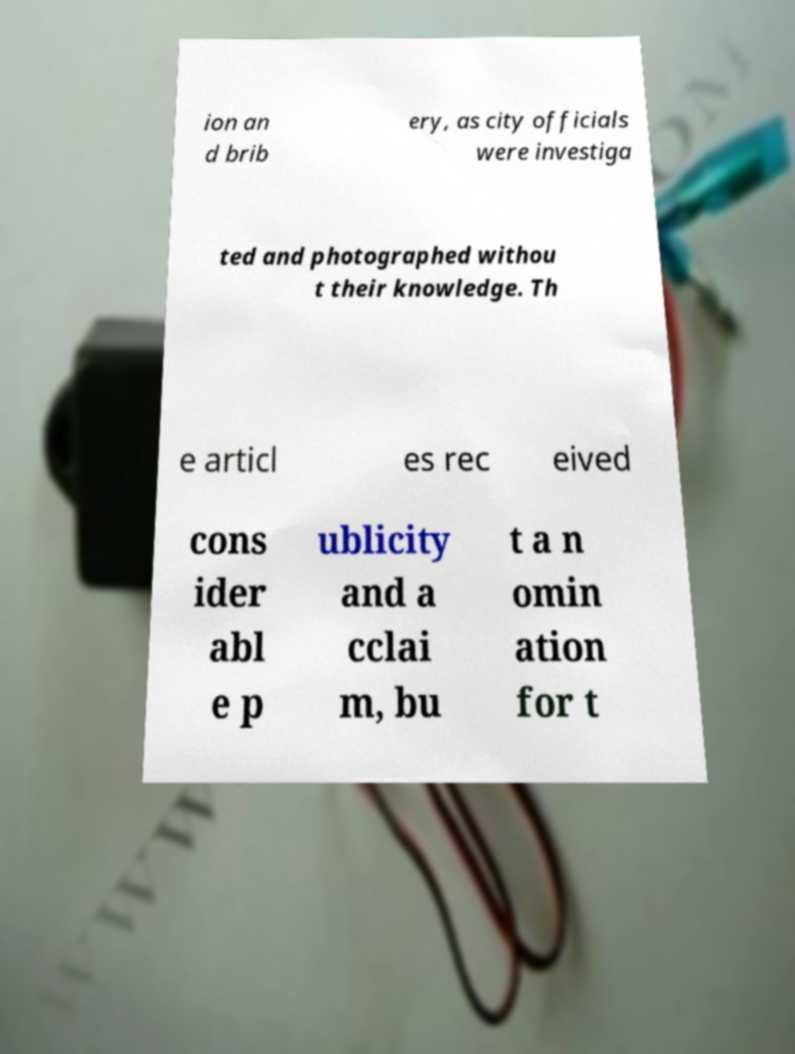Can you accurately transcribe the text from the provided image for me? ion an d brib ery, as city officials were investiga ted and photographed withou t their knowledge. Th e articl es rec eived cons ider abl e p ublicity and a cclai m, bu t a n omin ation for t 